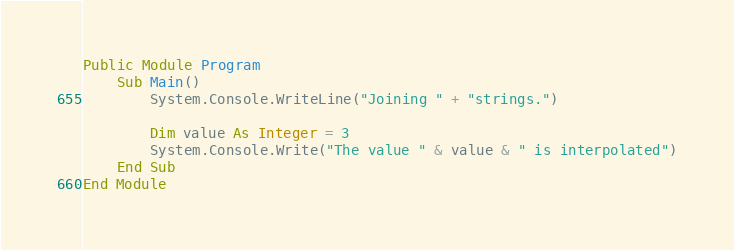<code> <loc_0><loc_0><loc_500><loc_500><_VisualBasic_>Public Module Program
    Sub Main()
        System.Console.WriteLine("Joining " + "strings.")
		
		Dim value As Integer = 3
		System.Console.Write("The value " & value & " is interpolated")
    End Sub
End Module</code> 